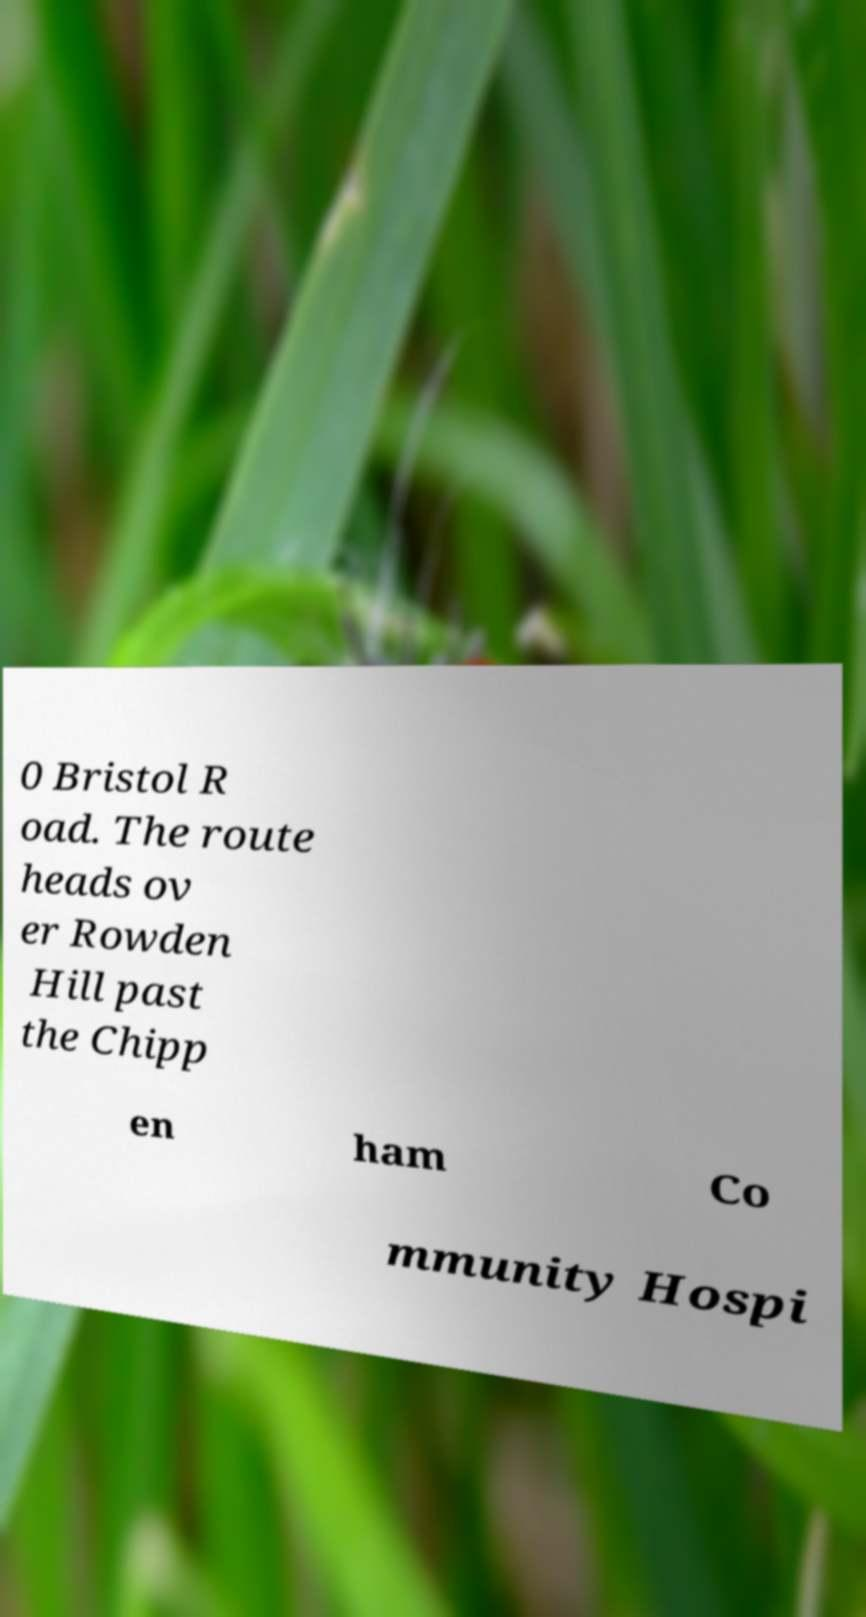For documentation purposes, I need the text within this image transcribed. Could you provide that? 0 Bristol R oad. The route heads ov er Rowden Hill past the Chipp en ham Co mmunity Hospi 